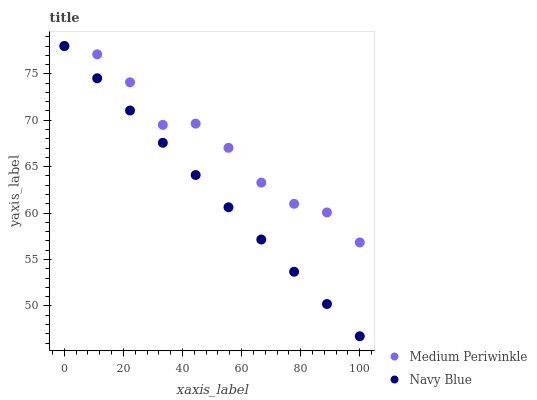Does Navy Blue have the minimum area under the curve?
Answer yes or no. Yes. Does Medium Periwinkle have the maximum area under the curve?
Answer yes or no. Yes. Does Medium Periwinkle have the minimum area under the curve?
Answer yes or no. No. Is Navy Blue the smoothest?
Answer yes or no. Yes. Is Medium Periwinkle the roughest?
Answer yes or no. Yes. Is Medium Periwinkle the smoothest?
Answer yes or no. No. Does Navy Blue have the lowest value?
Answer yes or no. Yes. Does Medium Periwinkle have the lowest value?
Answer yes or no. No. Does Medium Periwinkle have the highest value?
Answer yes or no. Yes. Does Navy Blue intersect Medium Periwinkle?
Answer yes or no. Yes. Is Navy Blue less than Medium Periwinkle?
Answer yes or no. No. Is Navy Blue greater than Medium Periwinkle?
Answer yes or no. No. 